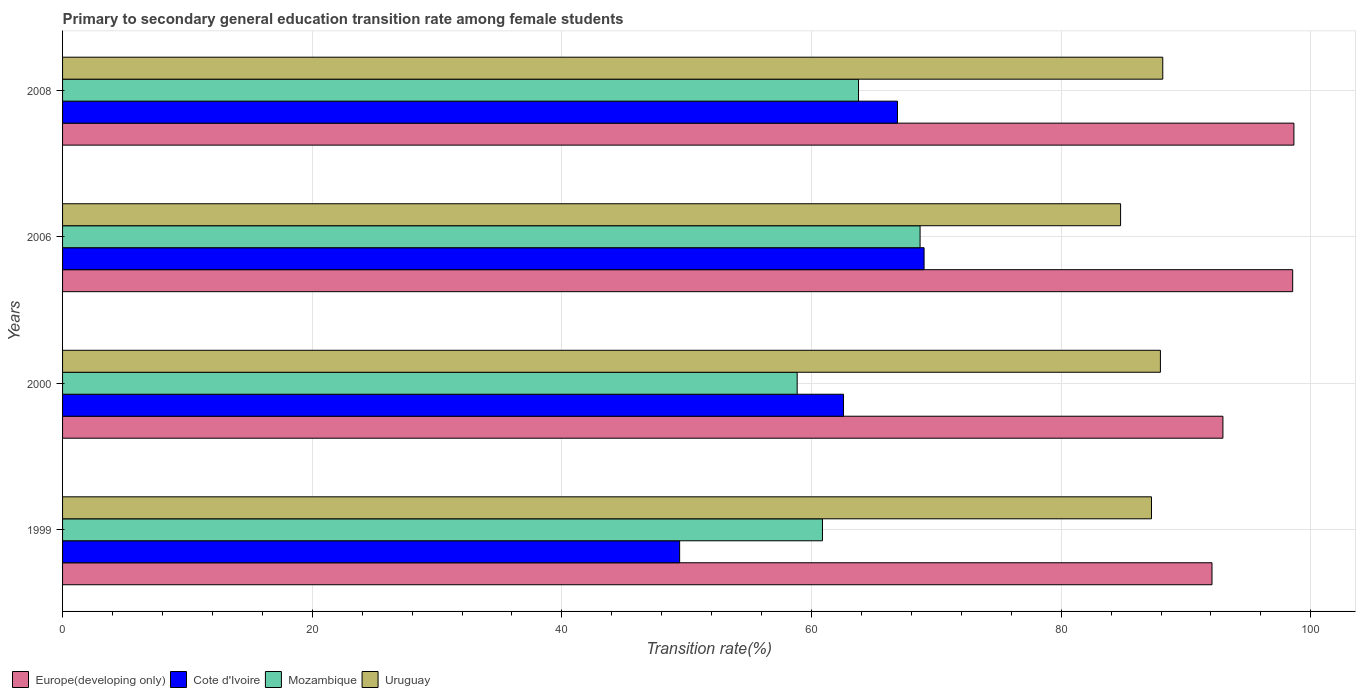In how many cases, is the number of bars for a given year not equal to the number of legend labels?
Ensure brevity in your answer.  0. What is the transition rate in Europe(developing only) in 2008?
Provide a succinct answer. 98.65. Across all years, what is the maximum transition rate in Cote d'Ivoire?
Your answer should be compact. 69.02. Across all years, what is the minimum transition rate in Europe(developing only)?
Give a very brief answer. 92.09. What is the total transition rate in Cote d'Ivoire in the graph?
Keep it short and to the point. 247.91. What is the difference between the transition rate in Europe(developing only) in 1999 and that in 2006?
Give a very brief answer. -6.46. What is the difference between the transition rate in Cote d'Ivoire in 2000 and the transition rate in Mozambique in 1999?
Ensure brevity in your answer.  1.69. What is the average transition rate in Europe(developing only) per year?
Ensure brevity in your answer.  95.56. In the year 2006, what is the difference between the transition rate in Europe(developing only) and transition rate in Mozambique?
Offer a terse response. 29.85. In how many years, is the transition rate in Cote d'Ivoire greater than 8 %?
Offer a very short reply. 4. What is the ratio of the transition rate in Mozambique in 1999 to that in 2000?
Provide a succinct answer. 1.03. Is the transition rate in Cote d'Ivoire in 2000 less than that in 2008?
Make the answer very short. Yes. What is the difference between the highest and the second highest transition rate in Cote d'Ivoire?
Ensure brevity in your answer.  2.13. What is the difference between the highest and the lowest transition rate in Mozambique?
Your answer should be very brief. 9.85. In how many years, is the transition rate in Mozambique greater than the average transition rate in Mozambique taken over all years?
Your response must be concise. 2. Is the sum of the transition rate in Mozambique in 2006 and 2008 greater than the maximum transition rate in Uruguay across all years?
Your answer should be very brief. Yes. Is it the case that in every year, the sum of the transition rate in Mozambique and transition rate in Europe(developing only) is greater than the sum of transition rate in Uruguay and transition rate in Cote d'Ivoire?
Provide a succinct answer. Yes. What does the 3rd bar from the top in 2000 represents?
Offer a very short reply. Cote d'Ivoire. What does the 1st bar from the bottom in 1999 represents?
Provide a succinct answer. Europe(developing only). Is it the case that in every year, the sum of the transition rate in Uruguay and transition rate in Cote d'Ivoire is greater than the transition rate in Europe(developing only)?
Your answer should be compact. Yes. Are all the bars in the graph horizontal?
Ensure brevity in your answer.  Yes. How many years are there in the graph?
Your answer should be very brief. 4. Does the graph contain grids?
Ensure brevity in your answer.  Yes. How many legend labels are there?
Keep it short and to the point. 4. What is the title of the graph?
Ensure brevity in your answer.  Primary to secondary general education transition rate among female students. What is the label or title of the X-axis?
Your answer should be compact. Transition rate(%). What is the label or title of the Y-axis?
Ensure brevity in your answer.  Years. What is the Transition rate(%) of Europe(developing only) in 1999?
Offer a very short reply. 92.09. What is the Transition rate(%) of Cote d'Ivoire in 1999?
Your answer should be very brief. 49.44. What is the Transition rate(%) in Mozambique in 1999?
Offer a very short reply. 60.88. What is the Transition rate(%) of Uruguay in 1999?
Make the answer very short. 87.24. What is the Transition rate(%) in Europe(developing only) in 2000?
Keep it short and to the point. 92.96. What is the Transition rate(%) of Cote d'Ivoire in 2000?
Your answer should be very brief. 62.56. What is the Transition rate(%) in Mozambique in 2000?
Ensure brevity in your answer.  58.85. What is the Transition rate(%) of Uruguay in 2000?
Keep it short and to the point. 87.95. What is the Transition rate(%) of Europe(developing only) in 2006?
Keep it short and to the point. 98.55. What is the Transition rate(%) in Cote d'Ivoire in 2006?
Provide a short and direct response. 69.02. What is the Transition rate(%) of Mozambique in 2006?
Offer a terse response. 68.7. What is the Transition rate(%) in Uruguay in 2006?
Provide a short and direct response. 84.76. What is the Transition rate(%) of Europe(developing only) in 2008?
Your answer should be compact. 98.65. What is the Transition rate(%) of Cote d'Ivoire in 2008?
Your answer should be compact. 66.89. What is the Transition rate(%) in Mozambique in 2008?
Your response must be concise. 63.77. What is the Transition rate(%) in Uruguay in 2008?
Your answer should be compact. 88.14. Across all years, what is the maximum Transition rate(%) in Europe(developing only)?
Give a very brief answer. 98.65. Across all years, what is the maximum Transition rate(%) of Cote d'Ivoire?
Keep it short and to the point. 69.02. Across all years, what is the maximum Transition rate(%) in Mozambique?
Ensure brevity in your answer.  68.7. Across all years, what is the maximum Transition rate(%) of Uruguay?
Offer a terse response. 88.14. Across all years, what is the minimum Transition rate(%) of Europe(developing only)?
Keep it short and to the point. 92.09. Across all years, what is the minimum Transition rate(%) in Cote d'Ivoire?
Ensure brevity in your answer.  49.44. Across all years, what is the minimum Transition rate(%) in Mozambique?
Provide a succinct answer. 58.85. Across all years, what is the minimum Transition rate(%) of Uruguay?
Your answer should be compact. 84.76. What is the total Transition rate(%) in Europe(developing only) in the graph?
Your answer should be very brief. 382.25. What is the total Transition rate(%) in Cote d'Ivoire in the graph?
Keep it short and to the point. 247.91. What is the total Transition rate(%) in Mozambique in the graph?
Your response must be concise. 252.2. What is the total Transition rate(%) in Uruguay in the graph?
Provide a succinct answer. 348.09. What is the difference between the Transition rate(%) in Europe(developing only) in 1999 and that in 2000?
Offer a very short reply. -0.88. What is the difference between the Transition rate(%) in Cote d'Ivoire in 1999 and that in 2000?
Your answer should be compact. -13.13. What is the difference between the Transition rate(%) in Mozambique in 1999 and that in 2000?
Your answer should be compact. 2.03. What is the difference between the Transition rate(%) of Uruguay in 1999 and that in 2000?
Ensure brevity in your answer.  -0.71. What is the difference between the Transition rate(%) of Europe(developing only) in 1999 and that in 2006?
Provide a succinct answer. -6.46. What is the difference between the Transition rate(%) of Cote d'Ivoire in 1999 and that in 2006?
Your answer should be very brief. -19.58. What is the difference between the Transition rate(%) of Mozambique in 1999 and that in 2006?
Your answer should be very brief. -7.82. What is the difference between the Transition rate(%) of Uruguay in 1999 and that in 2006?
Your response must be concise. 2.48. What is the difference between the Transition rate(%) in Europe(developing only) in 1999 and that in 2008?
Offer a terse response. -6.56. What is the difference between the Transition rate(%) of Cote d'Ivoire in 1999 and that in 2008?
Offer a very short reply. -17.45. What is the difference between the Transition rate(%) in Mozambique in 1999 and that in 2008?
Ensure brevity in your answer.  -2.89. What is the difference between the Transition rate(%) of Uruguay in 1999 and that in 2008?
Offer a very short reply. -0.9. What is the difference between the Transition rate(%) in Europe(developing only) in 2000 and that in 2006?
Your response must be concise. -5.59. What is the difference between the Transition rate(%) in Cote d'Ivoire in 2000 and that in 2006?
Provide a succinct answer. -6.45. What is the difference between the Transition rate(%) in Mozambique in 2000 and that in 2006?
Offer a terse response. -9.85. What is the difference between the Transition rate(%) of Uruguay in 2000 and that in 2006?
Keep it short and to the point. 3.19. What is the difference between the Transition rate(%) in Europe(developing only) in 2000 and that in 2008?
Your answer should be very brief. -5.69. What is the difference between the Transition rate(%) in Cote d'Ivoire in 2000 and that in 2008?
Your response must be concise. -4.33. What is the difference between the Transition rate(%) of Mozambique in 2000 and that in 2008?
Give a very brief answer. -4.91. What is the difference between the Transition rate(%) of Uruguay in 2000 and that in 2008?
Ensure brevity in your answer.  -0.19. What is the difference between the Transition rate(%) in Europe(developing only) in 2006 and that in 2008?
Your answer should be very brief. -0.1. What is the difference between the Transition rate(%) in Cote d'Ivoire in 2006 and that in 2008?
Give a very brief answer. 2.13. What is the difference between the Transition rate(%) of Mozambique in 2006 and that in 2008?
Make the answer very short. 4.93. What is the difference between the Transition rate(%) of Uruguay in 2006 and that in 2008?
Keep it short and to the point. -3.38. What is the difference between the Transition rate(%) of Europe(developing only) in 1999 and the Transition rate(%) of Cote d'Ivoire in 2000?
Provide a succinct answer. 29.52. What is the difference between the Transition rate(%) in Europe(developing only) in 1999 and the Transition rate(%) in Mozambique in 2000?
Your answer should be compact. 33.23. What is the difference between the Transition rate(%) in Europe(developing only) in 1999 and the Transition rate(%) in Uruguay in 2000?
Keep it short and to the point. 4.13. What is the difference between the Transition rate(%) of Cote d'Ivoire in 1999 and the Transition rate(%) of Mozambique in 2000?
Your response must be concise. -9.42. What is the difference between the Transition rate(%) of Cote d'Ivoire in 1999 and the Transition rate(%) of Uruguay in 2000?
Offer a terse response. -38.52. What is the difference between the Transition rate(%) in Mozambique in 1999 and the Transition rate(%) in Uruguay in 2000?
Offer a terse response. -27.07. What is the difference between the Transition rate(%) in Europe(developing only) in 1999 and the Transition rate(%) in Cote d'Ivoire in 2006?
Keep it short and to the point. 23.07. What is the difference between the Transition rate(%) in Europe(developing only) in 1999 and the Transition rate(%) in Mozambique in 2006?
Offer a very short reply. 23.39. What is the difference between the Transition rate(%) in Europe(developing only) in 1999 and the Transition rate(%) in Uruguay in 2006?
Your response must be concise. 7.32. What is the difference between the Transition rate(%) of Cote d'Ivoire in 1999 and the Transition rate(%) of Mozambique in 2006?
Your answer should be compact. -19.26. What is the difference between the Transition rate(%) in Cote d'Ivoire in 1999 and the Transition rate(%) in Uruguay in 2006?
Offer a very short reply. -35.32. What is the difference between the Transition rate(%) in Mozambique in 1999 and the Transition rate(%) in Uruguay in 2006?
Provide a succinct answer. -23.88. What is the difference between the Transition rate(%) of Europe(developing only) in 1999 and the Transition rate(%) of Cote d'Ivoire in 2008?
Make the answer very short. 25.2. What is the difference between the Transition rate(%) in Europe(developing only) in 1999 and the Transition rate(%) in Mozambique in 2008?
Provide a short and direct response. 28.32. What is the difference between the Transition rate(%) of Europe(developing only) in 1999 and the Transition rate(%) of Uruguay in 2008?
Give a very brief answer. 3.94. What is the difference between the Transition rate(%) in Cote d'Ivoire in 1999 and the Transition rate(%) in Mozambique in 2008?
Offer a very short reply. -14.33. What is the difference between the Transition rate(%) in Cote d'Ivoire in 1999 and the Transition rate(%) in Uruguay in 2008?
Give a very brief answer. -38.7. What is the difference between the Transition rate(%) in Mozambique in 1999 and the Transition rate(%) in Uruguay in 2008?
Keep it short and to the point. -27.26. What is the difference between the Transition rate(%) of Europe(developing only) in 2000 and the Transition rate(%) of Cote d'Ivoire in 2006?
Offer a very short reply. 23.94. What is the difference between the Transition rate(%) of Europe(developing only) in 2000 and the Transition rate(%) of Mozambique in 2006?
Offer a very short reply. 24.26. What is the difference between the Transition rate(%) in Europe(developing only) in 2000 and the Transition rate(%) in Uruguay in 2006?
Keep it short and to the point. 8.2. What is the difference between the Transition rate(%) of Cote d'Ivoire in 2000 and the Transition rate(%) of Mozambique in 2006?
Keep it short and to the point. -6.13. What is the difference between the Transition rate(%) in Cote d'Ivoire in 2000 and the Transition rate(%) in Uruguay in 2006?
Ensure brevity in your answer.  -22.2. What is the difference between the Transition rate(%) in Mozambique in 2000 and the Transition rate(%) in Uruguay in 2006?
Your response must be concise. -25.91. What is the difference between the Transition rate(%) in Europe(developing only) in 2000 and the Transition rate(%) in Cote d'Ivoire in 2008?
Provide a short and direct response. 26.07. What is the difference between the Transition rate(%) of Europe(developing only) in 2000 and the Transition rate(%) of Mozambique in 2008?
Ensure brevity in your answer.  29.19. What is the difference between the Transition rate(%) in Europe(developing only) in 2000 and the Transition rate(%) in Uruguay in 2008?
Provide a short and direct response. 4.82. What is the difference between the Transition rate(%) in Cote d'Ivoire in 2000 and the Transition rate(%) in Mozambique in 2008?
Make the answer very short. -1.2. What is the difference between the Transition rate(%) of Cote d'Ivoire in 2000 and the Transition rate(%) of Uruguay in 2008?
Offer a very short reply. -25.58. What is the difference between the Transition rate(%) of Mozambique in 2000 and the Transition rate(%) of Uruguay in 2008?
Ensure brevity in your answer.  -29.29. What is the difference between the Transition rate(%) of Europe(developing only) in 2006 and the Transition rate(%) of Cote d'Ivoire in 2008?
Provide a succinct answer. 31.66. What is the difference between the Transition rate(%) in Europe(developing only) in 2006 and the Transition rate(%) in Mozambique in 2008?
Provide a short and direct response. 34.78. What is the difference between the Transition rate(%) of Europe(developing only) in 2006 and the Transition rate(%) of Uruguay in 2008?
Keep it short and to the point. 10.41. What is the difference between the Transition rate(%) in Cote d'Ivoire in 2006 and the Transition rate(%) in Mozambique in 2008?
Keep it short and to the point. 5.25. What is the difference between the Transition rate(%) of Cote d'Ivoire in 2006 and the Transition rate(%) of Uruguay in 2008?
Make the answer very short. -19.12. What is the difference between the Transition rate(%) in Mozambique in 2006 and the Transition rate(%) in Uruguay in 2008?
Offer a very short reply. -19.44. What is the average Transition rate(%) of Europe(developing only) per year?
Provide a succinct answer. 95.56. What is the average Transition rate(%) of Cote d'Ivoire per year?
Offer a very short reply. 61.98. What is the average Transition rate(%) in Mozambique per year?
Make the answer very short. 63.05. What is the average Transition rate(%) in Uruguay per year?
Your response must be concise. 87.02. In the year 1999, what is the difference between the Transition rate(%) in Europe(developing only) and Transition rate(%) in Cote d'Ivoire?
Give a very brief answer. 42.65. In the year 1999, what is the difference between the Transition rate(%) of Europe(developing only) and Transition rate(%) of Mozambique?
Provide a short and direct response. 31.21. In the year 1999, what is the difference between the Transition rate(%) of Europe(developing only) and Transition rate(%) of Uruguay?
Offer a very short reply. 4.85. In the year 1999, what is the difference between the Transition rate(%) in Cote d'Ivoire and Transition rate(%) in Mozambique?
Offer a very short reply. -11.44. In the year 1999, what is the difference between the Transition rate(%) of Cote d'Ivoire and Transition rate(%) of Uruguay?
Provide a succinct answer. -37.8. In the year 1999, what is the difference between the Transition rate(%) in Mozambique and Transition rate(%) in Uruguay?
Provide a short and direct response. -26.36. In the year 2000, what is the difference between the Transition rate(%) in Europe(developing only) and Transition rate(%) in Cote d'Ivoire?
Offer a very short reply. 30.4. In the year 2000, what is the difference between the Transition rate(%) in Europe(developing only) and Transition rate(%) in Mozambique?
Ensure brevity in your answer.  34.11. In the year 2000, what is the difference between the Transition rate(%) in Europe(developing only) and Transition rate(%) in Uruguay?
Ensure brevity in your answer.  5.01. In the year 2000, what is the difference between the Transition rate(%) in Cote d'Ivoire and Transition rate(%) in Mozambique?
Ensure brevity in your answer.  3.71. In the year 2000, what is the difference between the Transition rate(%) of Cote d'Ivoire and Transition rate(%) of Uruguay?
Offer a terse response. -25.39. In the year 2000, what is the difference between the Transition rate(%) of Mozambique and Transition rate(%) of Uruguay?
Your answer should be compact. -29.1. In the year 2006, what is the difference between the Transition rate(%) of Europe(developing only) and Transition rate(%) of Cote d'Ivoire?
Give a very brief answer. 29.53. In the year 2006, what is the difference between the Transition rate(%) of Europe(developing only) and Transition rate(%) of Mozambique?
Offer a terse response. 29.85. In the year 2006, what is the difference between the Transition rate(%) in Europe(developing only) and Transition rate(%) in Uruguay?
Your response must be concise. 13.79. In the year 2006, what is the difference between the Transition rate(%) in Cote d'Ivoire and Transition rate(%) in Mozambique?
Provide a succinct answer. 0.32. In the year 2006, what is the difference between the Transition rate(%) of Cote d'Ivoire and Transition rate(%) of Uruguay?
Your response must be concise. -15.74. In the year 2006, what is the difference between the Transition rate(%) in Mozambique and Transition rate(%) in Uruguay?
Your response must be concise. -16.06. In the year 2008, what is the difference between the Transition rate(%) in Europe(developing only) and Transition rate(%) in Cote d'Ivoire?
Give a very brief answer. 31.76. In the year 2008, what is the difference between the Transition rate(%) in Europe(developing only) and Transition rate(%) in Mozambique?
Keep it short and to the point. 34.88. In the year 2008, what is the difference between the Transition rate(%) in Europe(developing only) and Transition rate(%) in Uruguay?
Provide a short and direct response. 10.51. In the year 2008, what is the difference between the Transition rate(%) of Cote d'Ivoire and Transition rate(%) of Mozambique?
Offer a terse response. 3.12. In the year 2008, what is the difference between the Transition rate(%) in Cote d'Ivoire and Transition rate(%) in Uruguay?
Keep it short and to the point. -21.25. In the year 2008, what is the difference between the Transition rate(%) of Mozambique and Transition rate(%) of Uruguay?
Offer a terse response. -24.37. What is the ratio of the Transition rate(%) of Europe(developing only) in 1999 to that in 2000?
Ensure brevity in your answer.  0.99. What is the ratio of the Transition rate(%) of Cote d'Ivoire in 1999 to that in 2000?
Your answer should be compact. 0.79. What is the ratio of the Transition rate(%) of Mozambique in 1999 to that in 2000?
Make the answer very short. 1.03. What is the ratio of the Transition rate(%) of Europe(developing only) in 1999 to that in 2006?
Make the answer very short. 0.93. What is the ratio of the Transition rate(%) of Cote d'Ivoire in 1999 to that in 2006?
Keep it short and to the point. 0.72. What is the ratio of the Transition rate(%) of Mozambique in 1999 to that in 2006?
Give a very brief answer. 0.89. What is the ratio of the Transition rate(%) of Uruguay in 1999 to that in 2006?
Provide a short and direct response. 1.03. What is the ratio of the Transition rate(%) in Europe(developing only) in 1999 to that in 2008?
Offer a very short reply. 0.93. What is the ratio of the Transition rate(%) in Cote d'Ivoire in 1999 to that in 2008?
Your answer should be very brief. 0.74. What is the ratio of the Transition rate(%) in Mozambique in 1999 to that in 2008?
Give a very brief answer. 0.95. What is the ratio of the Transition rate(%) of Europe(developing only) in 2000 to that in 2006?
Provide a short and direct response. 0.94. What is the ratio of the Transition rate(%) in Cote d'Ivoire in 2000 to that in 2006?
Your answer should be compact. 0.91. What is the ratio of the Transition rate(%) in Mozambique in 2000 to that in 2006?
Keep it short and to the point. 0.86. What is the ratio of the Transition rate(%) in Uruguay in 2000 to that in 2006?
Offer a very short reply. 1.04. What is the ratio of the Transition rate(%) of Europe(developing only) in 2000 to that in 2008?
Provide a short and direct response. 0.94. What is the ratio of the Transition rate(%) in Cote d'Ivoire in 2000 to that in 2008?
Your answer should be compact. 0.94. What is the ratio of the Transition rate(%) in Mozambique in 2000 to that in 2008?
Offer a very short reply. 0.92. What is the ratio of the Transition rate(%) of Uruguay in 2000 to that in 2008?
Your answer should be very brief. 1. What is the ratio of the Transition rate(%) in Cote d'Ivoire in 2006 to that in 2008?
Provide a short and direct response. 1.03. What is the ratio of the Transition rate(%) of Mozambique in 2006 to that in 2008?
Your answer should be very brief. 1.08. What is the ratio of the Transition rate(%) of Uruguay in 2006 to that in 2008?
Provide a succinct answer. 0.96. What is the difference between the highest and the second highest Transition rate(%) of Europe(developing only)?
Make the answer very short. 0.1. What is the difference between the highest and the second highest Transition rate(%) of Cote d'Ivoire?
Offer a terse response. 2.13. What is the difference between the highest and the second highest Transition rate(%) in Mozambique?
Provide a short and direct response. 4.93. What is the difference between the highest and the second highest Transition rate(%) in Uruguay?
Give a very brief answer. 0.19. What is the difference between the highest and the lowest Transition rate(%) of Europe(developing only)?
Ensure brevity in your answer.  6.56. What is the difference between the highest and the lowest Transition rate(%) of Cote d'Ivoire?
Offer a terse response. 19.58. What is the difference between the highest and the lowest Transition rate(%) of Mozambique?
Provide a succinct answer. 9.85. What is the difference between the highest and the lowest Transition rate(%) in Uruguay?
Provide a succinct answer. 3.38. 